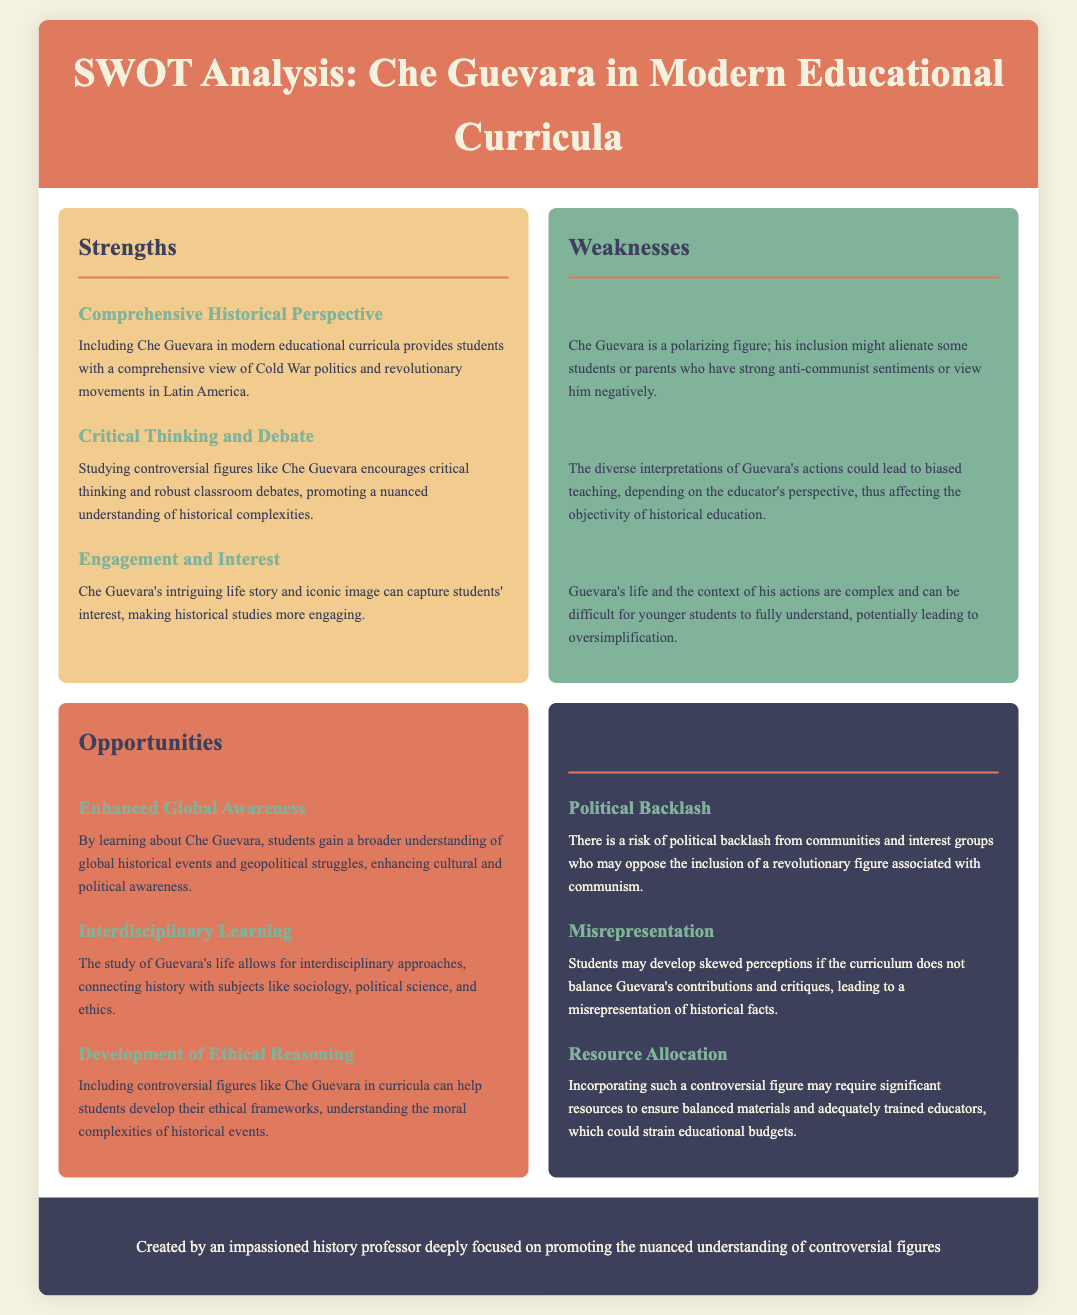What is the title of the document? The title of the document is explicitly stated in the header section of the rendered document.
Answer: SWOT Analysis: Che Guevara in Modern Educational Curricula How many strengths are listed in the analysis? The document outlines specific sections for strengths, weaknesses, opportunities, and threats, with three items listed under strengths.
Answer: 3 What color represents the weaknesses section? Each section of the analysis is color-coded, and the color for the weaknesses section is mentioned in the document.
Answer: Green What opportunity is associated with ethical reasoning? The opportunities section includes various items, one of which specifically mentions the development of ethical reasoning.
Answer: Development of Ethical Reasoning What is a potential threat mentioned in relation to political reactions? The document outlines specific threats associated with the inclusion of Che Guevara in curricula, including the potential for political backlash.
Answer: Political Backlash How does the inclusion of Che Guevara affect student engagement? The document notes how Che Guevara's life can influence student interest in historical studies, particularly highlighted in the strengths section.
Answer: Engaging What is a major weakness concerning perceptions of Che Guevara? The weaknesses section addresses potential difficulties or controversies surrounding how students may perceive Che Guevara.
Answer: Polarized Perceptions Which interdisciplinary subject can be connected with Guevara's studies? The opportunities section discusses various fields that could connect with Guevara's life, including sociology and other disciplines.
Answer: Sociology What is the main goal expressed in the document's footer? The footer summarizes the intention behind creating this analysis, focusing on the understanding of controversial figures.
Answer: Promote nuanced understanding 